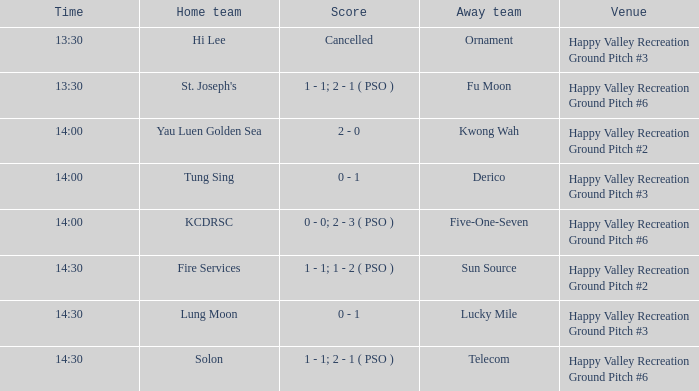At happy valley recreation ground pitch #2, what's the score for the match that began at 14:30? 1 - 1; 1 - 2 ( PSO ). Parse the table in full. {'header': ['Time', 'Home team', 'Score', 'Away team', 'Venue'], 'rows': [['13:30', 'Hi Lee', 'Cancelled', 'Ornament', 'Happy Valley Recreation Ground Pitch #3'], ['13:30', "St. Joseph's", '1 - 1; 2 - 1 ( PSO )', 'Fu Moon', 'Happy Valley Recreation Ground Pitch #6'], ['14:00', 'Yau Luen Golden Sea', '2 - 0', 'Kwong Wah', 'Happy Valley Recreation Ground Pitch #2'], ['14:00', 'Tung Sing', '0 - 1', 'Derico', 'Happy Valley Recreation Ground Pitch #3'], ['14:00', 'KCDRSC', '0 - 0; 2 - 3 ( PSO )', 'Five-One-Seven', 'Happy Valley Recreation Ground Pitch #6'], ['14:30', 'Fire Services', '1 - 1; 1 - 2 ( PSO )', 'Sun Source', 'Happy Valley Recreation Ground Pitch #2'], ['14:30', 'Lung Moon', '0 - 1', 'Lucky Mile', 'Happy Valley Recreation Ground Pitch #3'], ['14:30', 'Solon', '1 - 1; 2 - 1 ( PSO )', 'Telecom', 'Happy Valley Recreation Ground Pitch #6']]} 